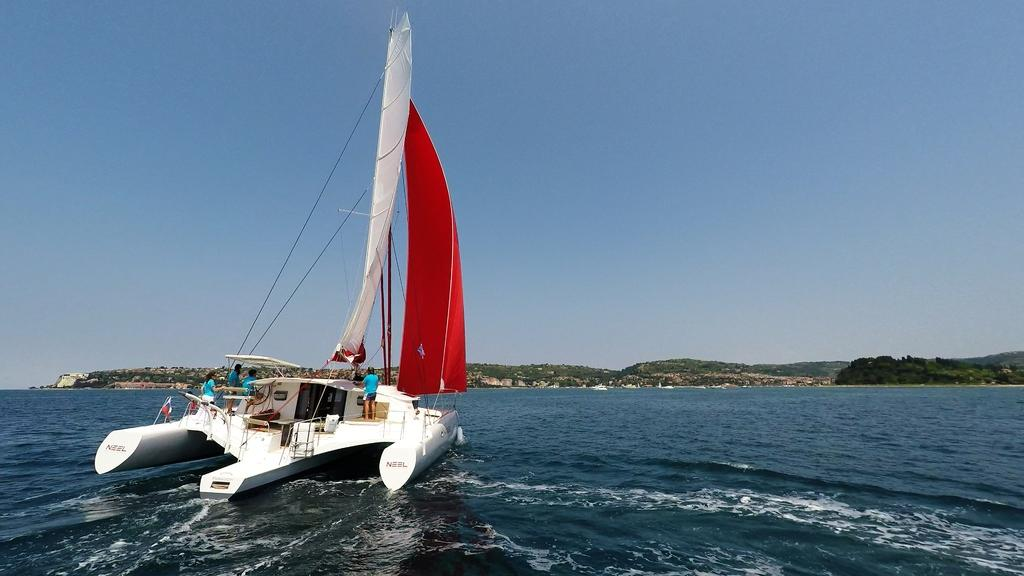What is the main subject of the image? The main subject of the image is a boat. Where is the boat located? The boat is on the water. Can you describe the people in the boat? There is a group of people in the boat, and they are wearing blue color dresses. What can be seen in the background of the image? In the background of the image, there are trees, mountains, and the sky. How many clams are visible on the boat in the image? There are no clams visible on the boat in the image. What type of patch is sewn onto the boat in the image? There is no patch visible on the boat in the image. 